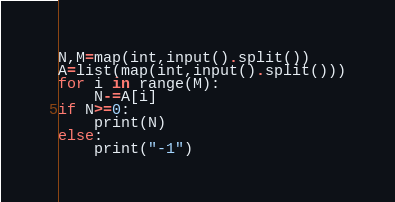Convert code to text. <code><loc_0><loc_0><loc_500><loc_500><_Python_>N,M=map(int,input().split())
A=list(map(int,input().split()))
for i in range(M):
    N-=A[i]
if N>=0:
    print(N)
else:
    print("-1")</code> 